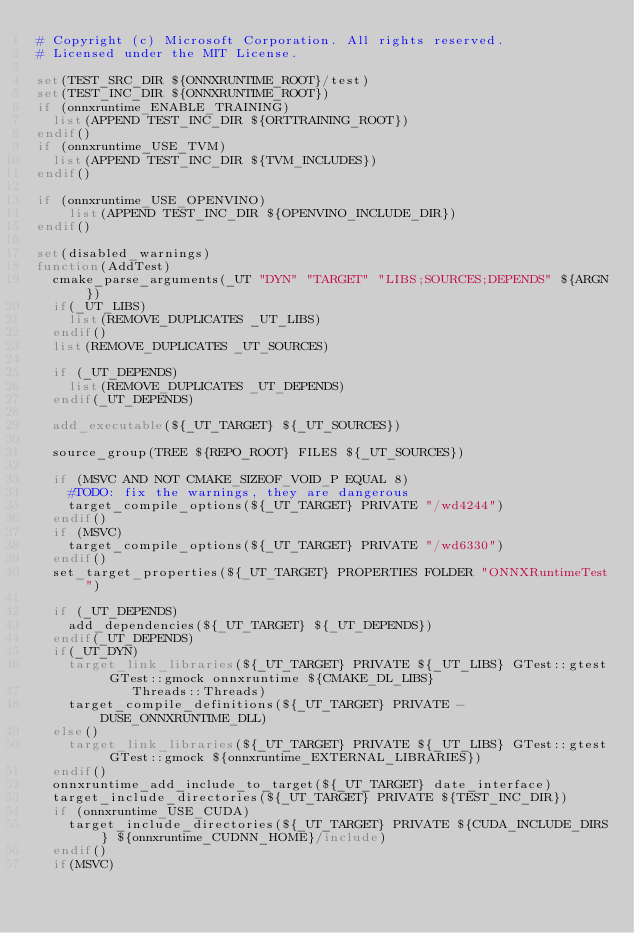Convert code to text. <code><loc_0><loc_0><loc_500><loc_500><_CMake_># Copyright (c) Microsoft Corporation. All rights reserved.
# Licensed under the MIT License.

set(TEST_SRC_DIR ${ONNXRUNTIME_ROOT}/test)
set(TEST_INC_DIR ${ONNXRUNTIME_ROOT})
if (onnxruntime_ENABLE_TRAINING)
  list(APPEND TEST_INC_DIR ${ORTTRAINING_ROOT})
endif()
if (onnxruntime_USE_TVM)
  list(APPEND TEST_INC_DIR ${TVM_INCLUDES})
endif()

if (onnxruntime_USE_OPENVINO)
    list(APPEND TEST_INC_DIR ${OPENVINO_INCLUDE_DIR})
endif()

set(disabled_warnings)
function(AddTest)
  cmake_parse_arguments(_UT "DYN" "TARGET" "LIBS;SOURCES;DEPENDS" ${ARGN})
  if(_UT_LIBS)
    list(REMOVE_DUPLICATES _UT_LIBS)
  endif()
  list(REMOVE_DUPLICATES _UT_SOURCES)

  if (_UT_DEPENDS)
    list(REMOVE_DUPLICATES _UT_DEPENDS)
  endif(_UT_DEPENDS)

  add_executable(${_UT_TARGET} ${_UT_SOURCES})

  source_group(TREE ${REPO_ROOT} FILES ${_UT_SOURCES})

  if (MSVC AND NOT CMAKE_SIZEOF_VOID_P EQUAL 8)
    #TODO: fix the warnings, they are dangerous
    target_compile_options(${_UT_TARGET} PRIVATE "/wd4244")
  endif()
  if (MSVC)
    target_compile_options(${_UT_TARGET} PRIVATE "/wd6330")
  endif()
  set_target_properties(${_UT_TARGET} PROPERTIES FOLDER "ONNXRuntimeTest")

  if (_UT_DEPENDS)
    add_dependencies(${_UT_TARGET} ${_UT_DEPENDS})
  endif(_UT_DEPENDS)
  if(_UT_DYN)
    target_link_libraries(${_UT_TARGET} PRIVATE ${_UT_LIBS} GTest::gtest GTest::gmock onnxruntime ${CMAKE_DL_LIBS}
            Threads::Threads)
    target_compile_definitions(${_UT_TARGET} PRIVATE -DUSE_ONNXRUNTIME_DLL)
  else()
    target_link_libraries(${_UT_TARGET} PRIVATE ${_UT_LIBS} GTest::gtest GTest::gmock ${onnxruntime_EXTERNAL_LIBRARIES})
  endif()
  onnxruntime_add_include_to_target(${_UT_TARGET} date_interface)
  target_include_directories(${_UT_TARGET} PRIVATE ${TEST_INC_DIR})
  if (onnxruntime_USE_CUDA)
    target_include_directories(${_UT_TARGET} PRIVATE ${CUDA_INCLUDE_DIRS} ${onnxruntime_CUDNN_HOME}/include)
  endif()
  if(MSVC)</code> 